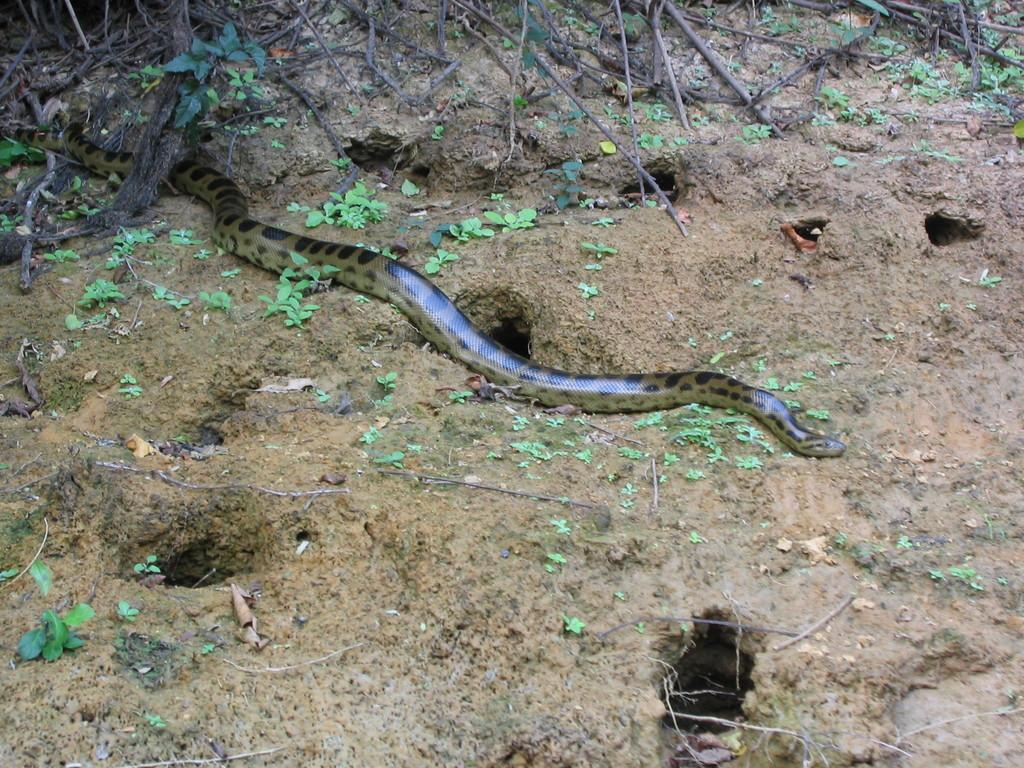What animal is present in the picture? There is a snake in the picture. What is a characteristic feature of the snake's body? The snake has scales on its body. What type of vegetation can be seen in the picture? There are small plants in the picture. What feature of the ground is visible in the picture? There are holes in the ground. What can be seen in the background of the picture? There are twigs in the background of the picture. What committee is responsible for maintaining the snake's habitat in the image? There is no committee present in the image, and the snake's habitat is not maintained by any specific group. How many spiders can be seen in the image? There are no spiders present in the image. 